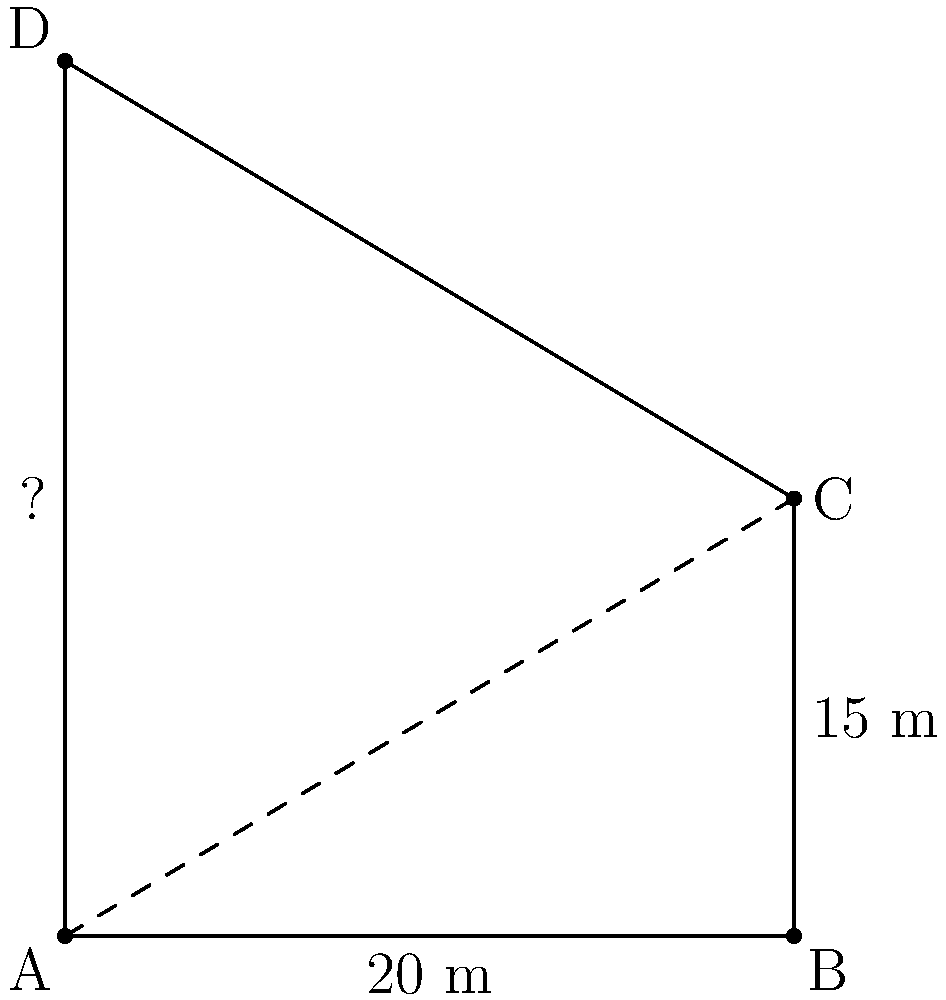At a crime scene, investigators need to determine the height of a building. They sketch a diagram as shown above. If the distance from point A to B is 20 meters, and the distance from B to C is 15 meters, what is the height of the building (distance from A to D) in meters? To solve this problem, we can use the concept of similar triangles. Let's follow these steps:

1) We can see that triangles ABC and ACD are similar, as they share an angle at A and both have a right angle.

2) In similar triangles, the ratio of corresponding sides is constant. We can set up the following proportion:

   $$\frac{AC}{AD} = \frac{AB}{AC}$$

3) We know AB = 20 m, and BC = 15 m. We need to find AC using the Pythagorean theorem:

   $$AC^2 = AB^2 + BC^2$$
   $$AC^2 = 20^2 + 15^2 = 400 + 225 = 625$$
   $$AC = \sqrt{625} = 25$$

4) Now we can substitute these values into our proportion:

   $$\frac{25}{AD} = \frac{20}{25}$$

5) Cross multiply:

   $$25 \times 25 = 20 \times AD$$
   $$625 = 20AD$$

6) Solve for AD:

   $$AD = \frac{625}{20} = 31.25$$

Therefore, the height of the building (AD) is 31.25 meters.
Answer: 31.25 meters 